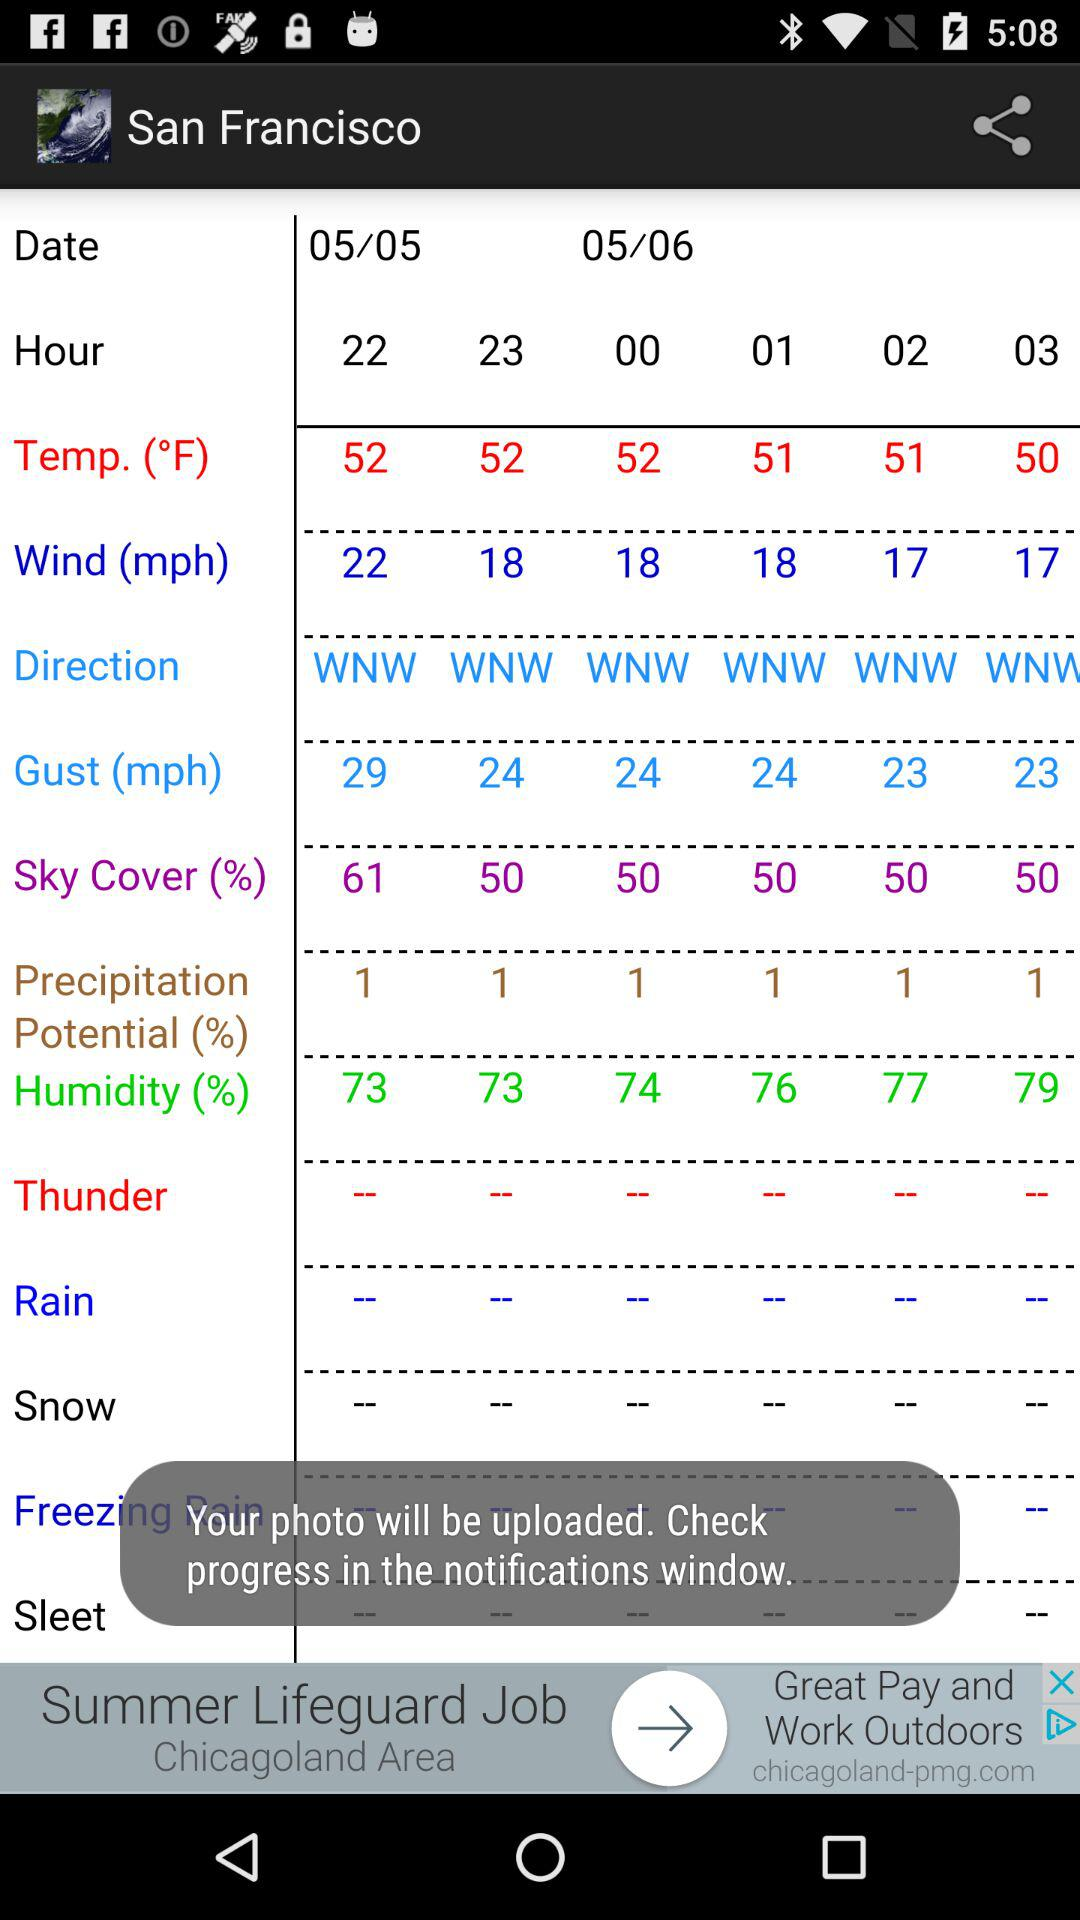Which city's data is shown? The data is shown for San Francisco. 